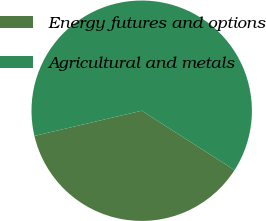Convert chart to OTSL. <chart><loc_0><loc_0><loc_500><loc_500><pie_chart><fcel>Energy futures and options<fcel>Agricultural and metals<nl><fcel>37.27%<fcel>62.73%<nl></chart> 